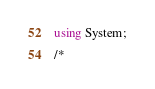Convert code to text. <code><loc_0><loc_0><loc_500><loc_500><_C#_>using System;

/*</code> 